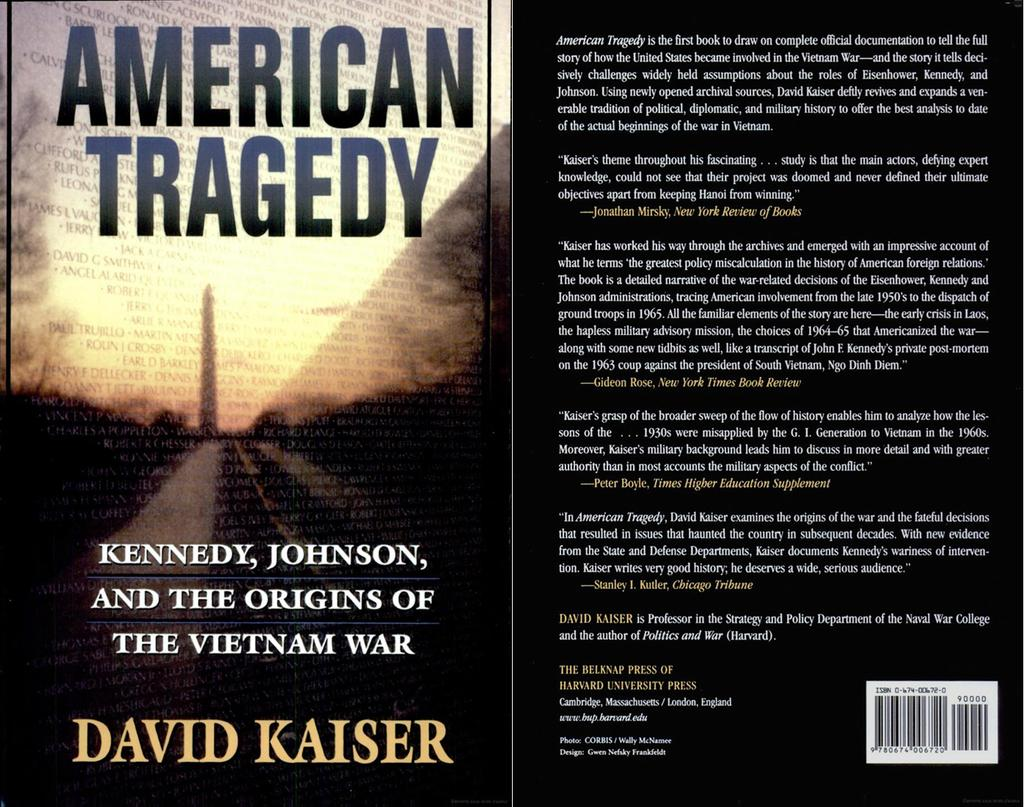<image>
Relay a brief, clear account of the picture shown. A book Called American Tragedy by David Kaiser showing the front and back side of the book. 